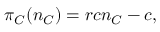<formula> <loc_0><loc_0><loc_500><loc_500>\pi _ { C } ( n _ { C } ) = r c n _ { C } - c ,</formula> 